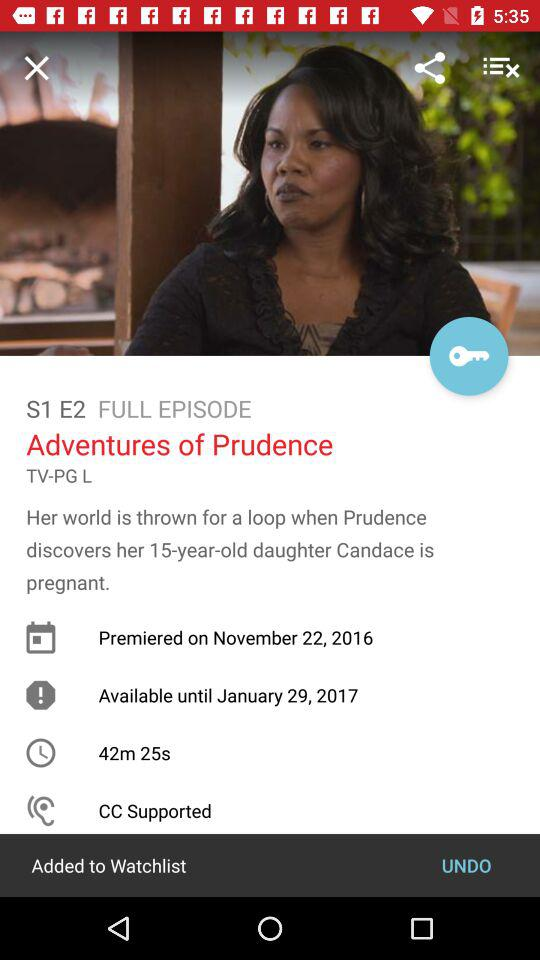Which episode is this? The episode is "Adventures of Prudence". 